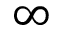Convert formula to latex. <formula><loc_0><loc_0><loc_500><loc_500>\infty</formula> 